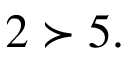Convert formula to latex. <formula><loc_0><loc_0><loc_500><loc_500>2 \succ 5 .</formula> 